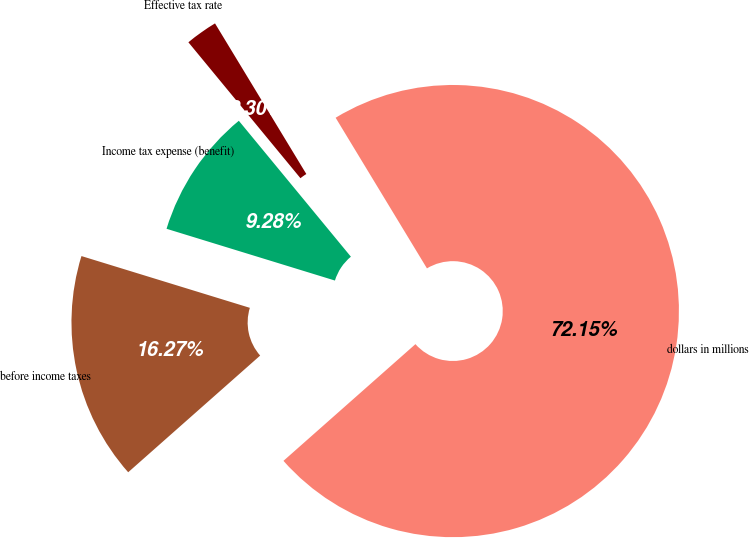Convert chart. <chart><loc_0><loc_0><loc_500><loc_500><pie_chart><fcel>dollars in millions<fcel>before income taxes<fcel>Income tax expense (benefit)<fcel>Effective tax rate<nl><fcel>72.15%<fcel>16.27%<fcel>9.28%<fcel>2.3%<nl></chart> 